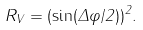<formula> <loc_0><loc_0><loc_500><loc_500>R _ { V } = ( \sin ( \Delta \varphi / 2 ) ) ^ { 2 } .</formula> 